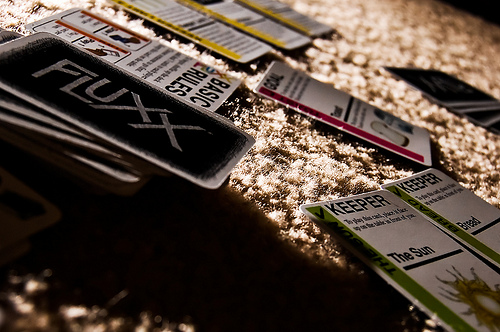<image>
Can you confirm if the card is next to the rug? Yes. The card is positioned adjacent to the rug, located nearby in the same general area. 